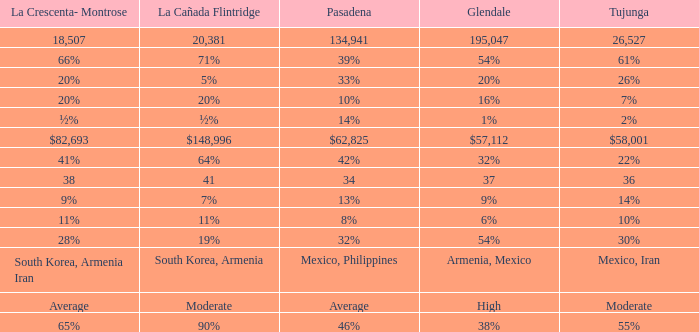What is the percentage of Tukunga when La Crescenta-Montrose is 28%? 30%. 